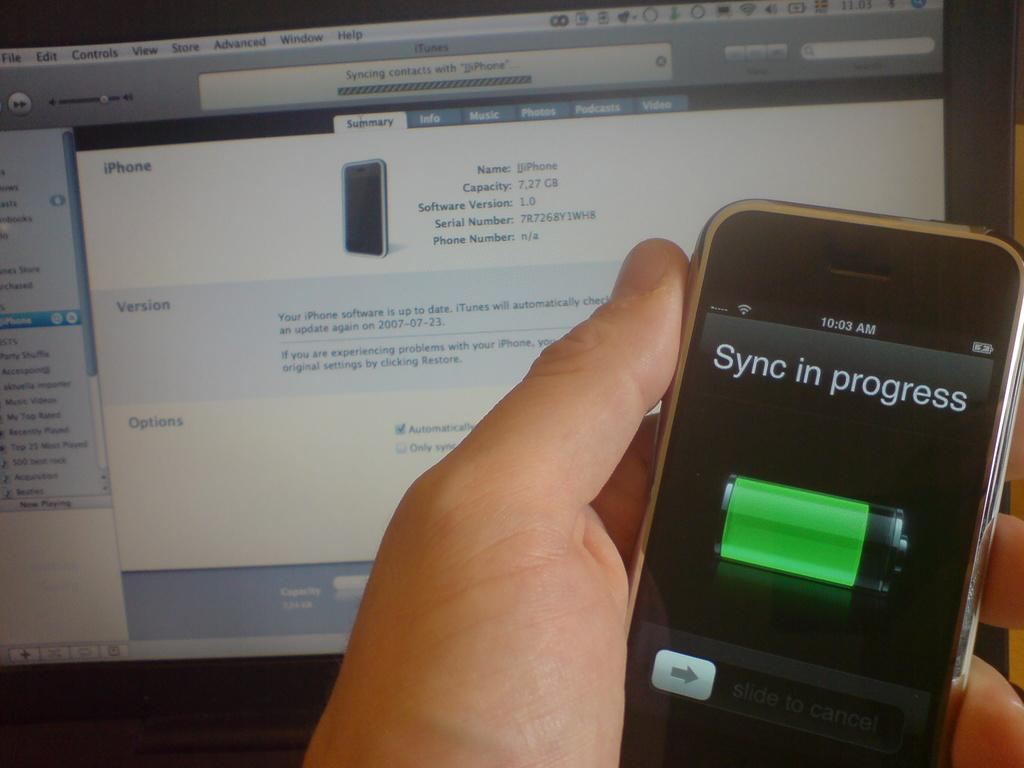<image>
Give a short and clear explanation of the subsequent image. a cell phone displaying words Sync in Progress 